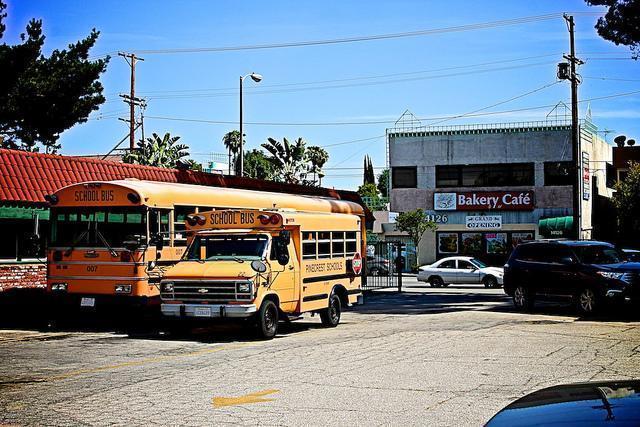When stopped what part of the smaller bus might most frequently pop out away from it's side?
Make your selection from the four choices given to correctly answer the question.
Options: Tires, tail pipe, hood, stop sign. Stop sign. 